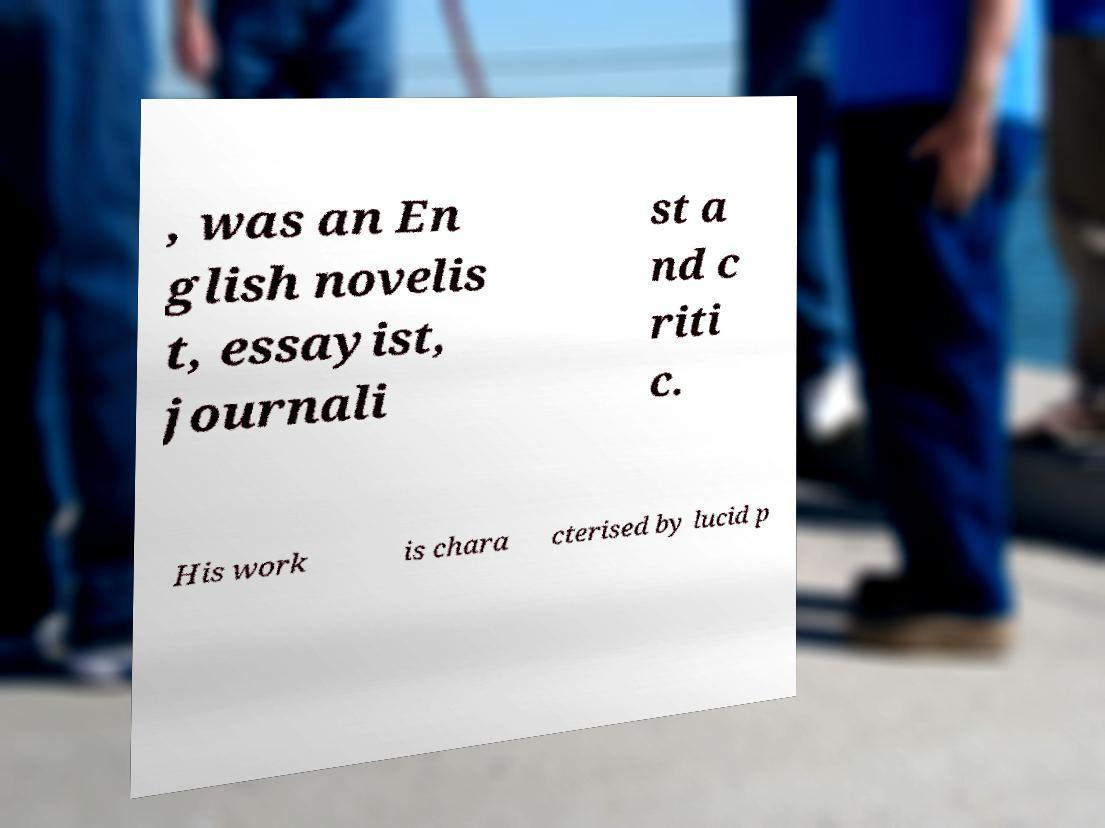I need the written content from this picture converted into text. Can you do that? , was an En glish novelis t, essayist, journali st a nd c riti c. His work is chara cterised by lucid p 